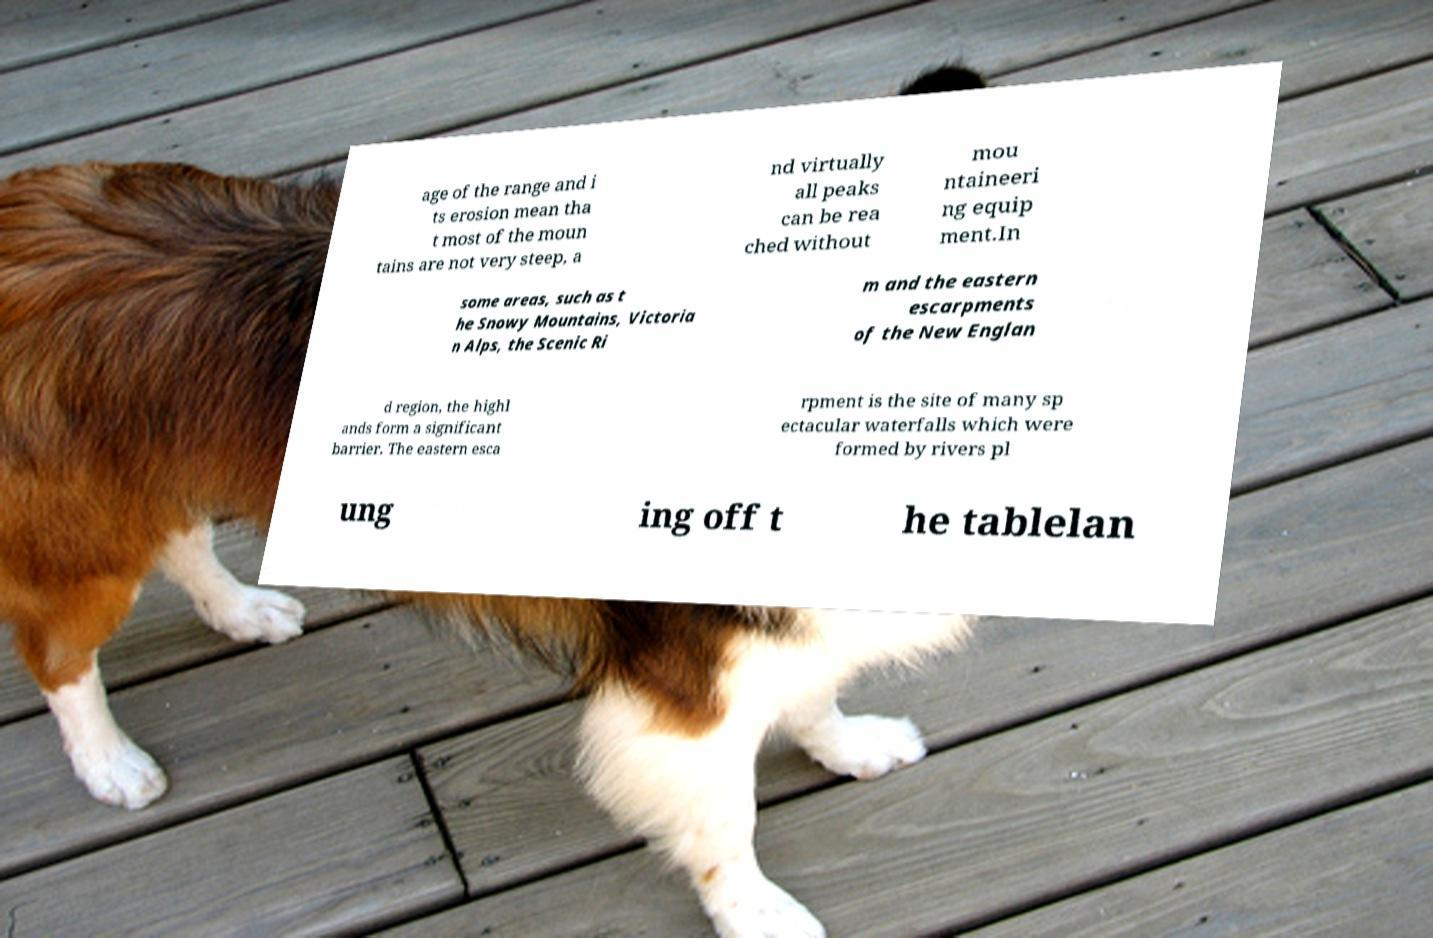Please read and relay the text visible in this image. What does it say? age of the range and i ts erosion mean tha t most of the moun tains are not very steep, a nd virtually all peaks can be rea ched without mou ntaineeri ng equip ment.In some areas, such as t he Snowy Mountains, Victoria n Alps, the Scenic Ri m and the eastern escarpments of the New Englan d region, the highl ands form a significant barrier. The eastern esca rpment is the site of many sp ectacular waterfalls which were formed by rivers pl ung ing off t he tablelan 